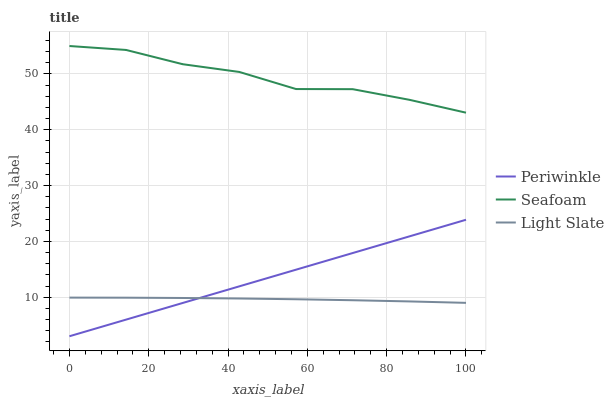Does Light Slate have the minimum area under the curve?
Answer yes or no. Yes. Does Seafoam have the maximum area under the curve?
Answer yes or no. Yes. Does Periwinkle have the minimum area under the curve?
Answer yes or no. No. Does Periwinkle have the maximum area under the curve?
Answer yes or no. No. Is Periwinkle the smoothest?
Answer yes or no. Yes. Is Seafoam the roughest?
Answer yes or no. Yes. Is Seafoam the smoothest?
Answer yes or no. No. Is Periwinkle the roughest?
Answer yes or no. No. Does Periwinkle have the lowest value?
Answer yes or no. Yes. Does Seafoam have the lowest value?
Answer yes or no. No. Does Seafoam have the highest value?
Answer yes or no. Yes. Does Periwinkle have the highest value?
Answer yes or no. No. Is Light Slate less than Seafoam?
Answer yes or no. Yes. Is Seafoam greater than Light Slate?
Answer yes or no. Yes. Does Periwinkle intersect Light Slate?
Answer yes or no. Yes. Is Periwinkle less than Light Slate?
Answer yes or no. No. Is Periwinkle greater than Light Slate?
Answer yes or no. No. Does Light Slate intersect Seafoam?
Answer yes or no. No. 